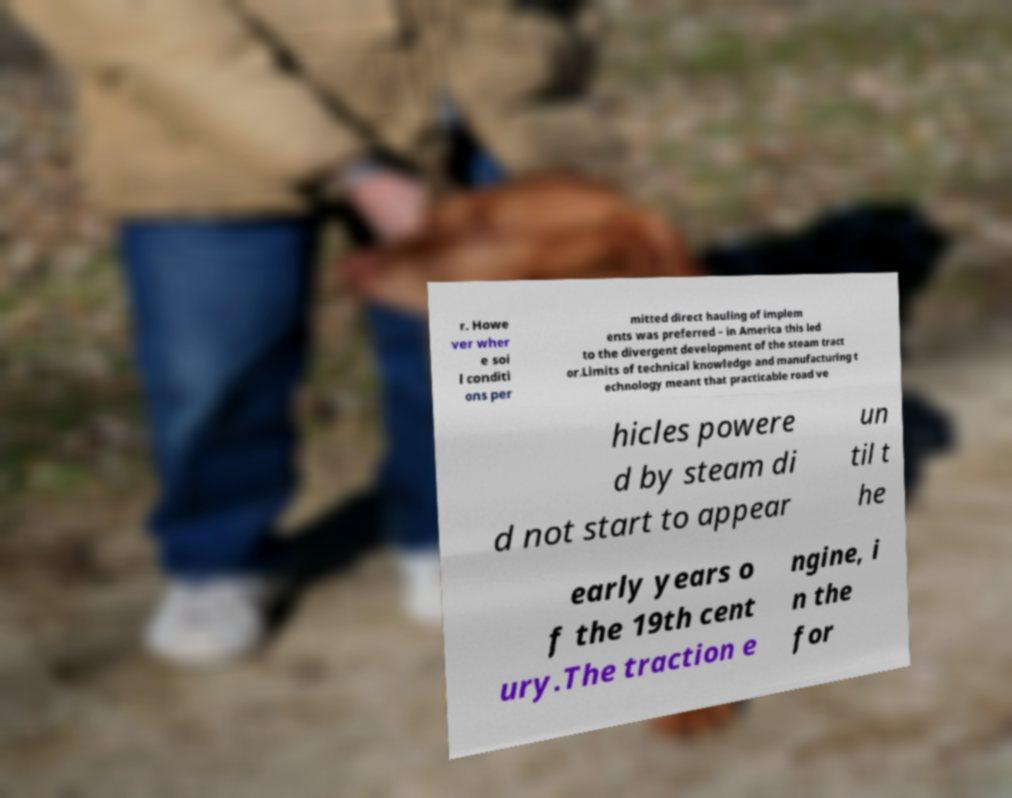Please identify and transcribe the text found in this image. r. Howe ver wher e soi l conditi ons per mitted direct hauling of implem ents was preferred – in America this led to the divergent development of the steam tract or.Limits of technical knowledge and manufacturing t echnology meant that practicable road ve hicles powere d by steam di d not start to appear un til t he early years o f the 19th cent ury.The traction e ngine, i n the for 